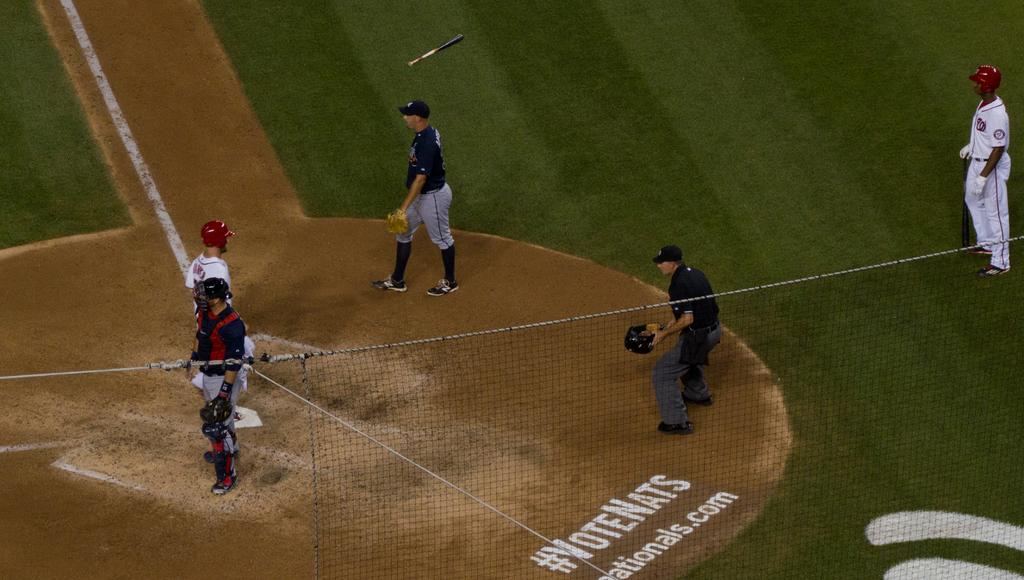<image>
Describe the image concisely. A baseball diamond where an advertisement behind home plate states #VoteNats 